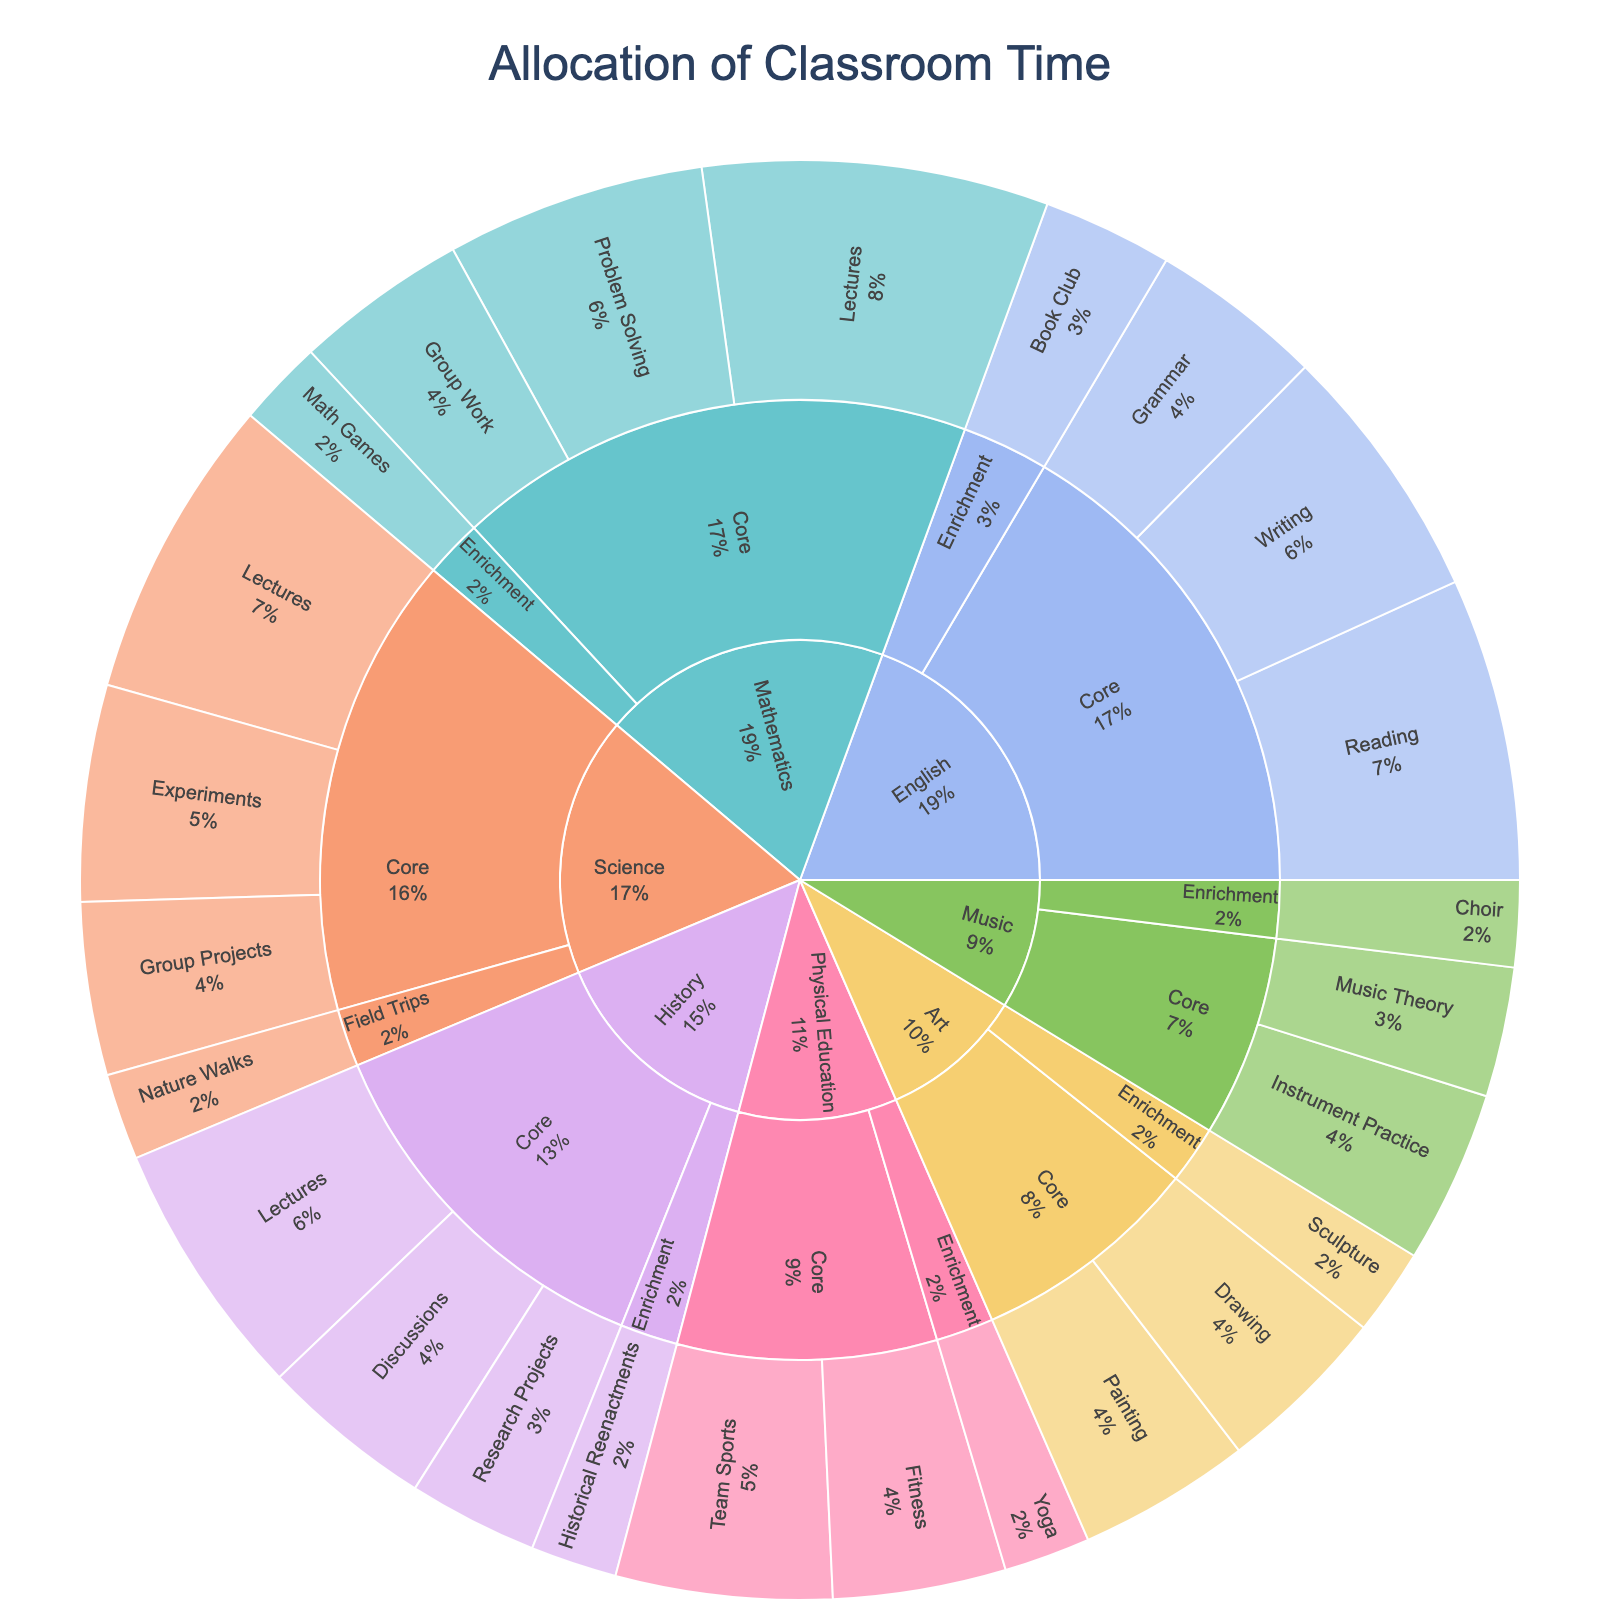What is the total time allocated to Mathematics? Combine the time from all activities under Mathematics: Lectures (80) + Problem Solving (60) + Group Work (40) + Math Games (20) which sums up to 200.
Answer: 200 Which subject has the least amount of time for Enrichment activities? Look at the Enrichment activities for all subjects and sum their times: Mathematics (20), Science (20), English (30), History (20), Art (20), Physical Education (20), Music (20). All have the same amount except for English with more time. Thus, the subjects with the least time are Mathematics, Science, History, Art, Physical Education, and Music.
Answer: Mathematics, Science, History, Art, Physical Education, Music How much time is allocated to all Core activities combined? Sum all the times for Core activities across all subjects: Mathematics (180), Science (160), English (170), History (130), Art (80), Physical Education (90), Music (70). The total is 180+160+170+130+80+90+70 = 880.
Answer: 880 Compare the time allocated to Core Lectures in Mathematics and Science. Which one has more, and by how much? Compare the times for Lectures: Mathematics (80) and Science (70). Mathematics has 10 more hours than Science.
Answer: Mathematics by 10 What proportion of the total time is allocated to English activities? First, calculate the total time for English: Core (170) + Enrichment (30) = 200. Then calculate the total time for all subjects combined (already done in a previous explanation, 1180). The proportion is 200/1180 which is approximately 0.1695 or 16.95%.
Answer: 16.95% What is the most time-consuming activity in Physical Education? Look at the time allocated to different activities in Physical Education: Team Sports (50), Fitness (40), Yoga (20). The most time-consuming activity is Team Sports.
Answer: Team Sports Which subject has the highest proportion of time allocated to Enrichment activities? Calculate the proportion for Enrichment time by dividing the Enrichment time by the total time for each subject. Mathematics: 20/200, Science: 20/180, English: 30/200, History: 20/150, Art: 20/100, Physical Education: 20/110, Music: 20/90. Music has the highest proportion which is 20/90 ≈ 0.2222 or 22.22%.
Answer: Music What percentage of the total school time is spent on Science experiments? The total time is 1180 and the time for Science experiments is 50. So, 50/1180 which is 0.0424 or 4.24%.
Answer: 4.24% What is the least time-consuming activity overall? Identify the activity with the least allocated time, which includes checking all activities across subjects: Math Games (20), Nature Walks (20), Book Club (30), Historical Reenactments (20), Sculpture (20), Yoga (20), Choir (20). All except Book Club are least time-consuming, each with 20 hours.
Answer: Math Games, Nature Walks, Historical Reenactments, Sculpture, Yoga, Choir 